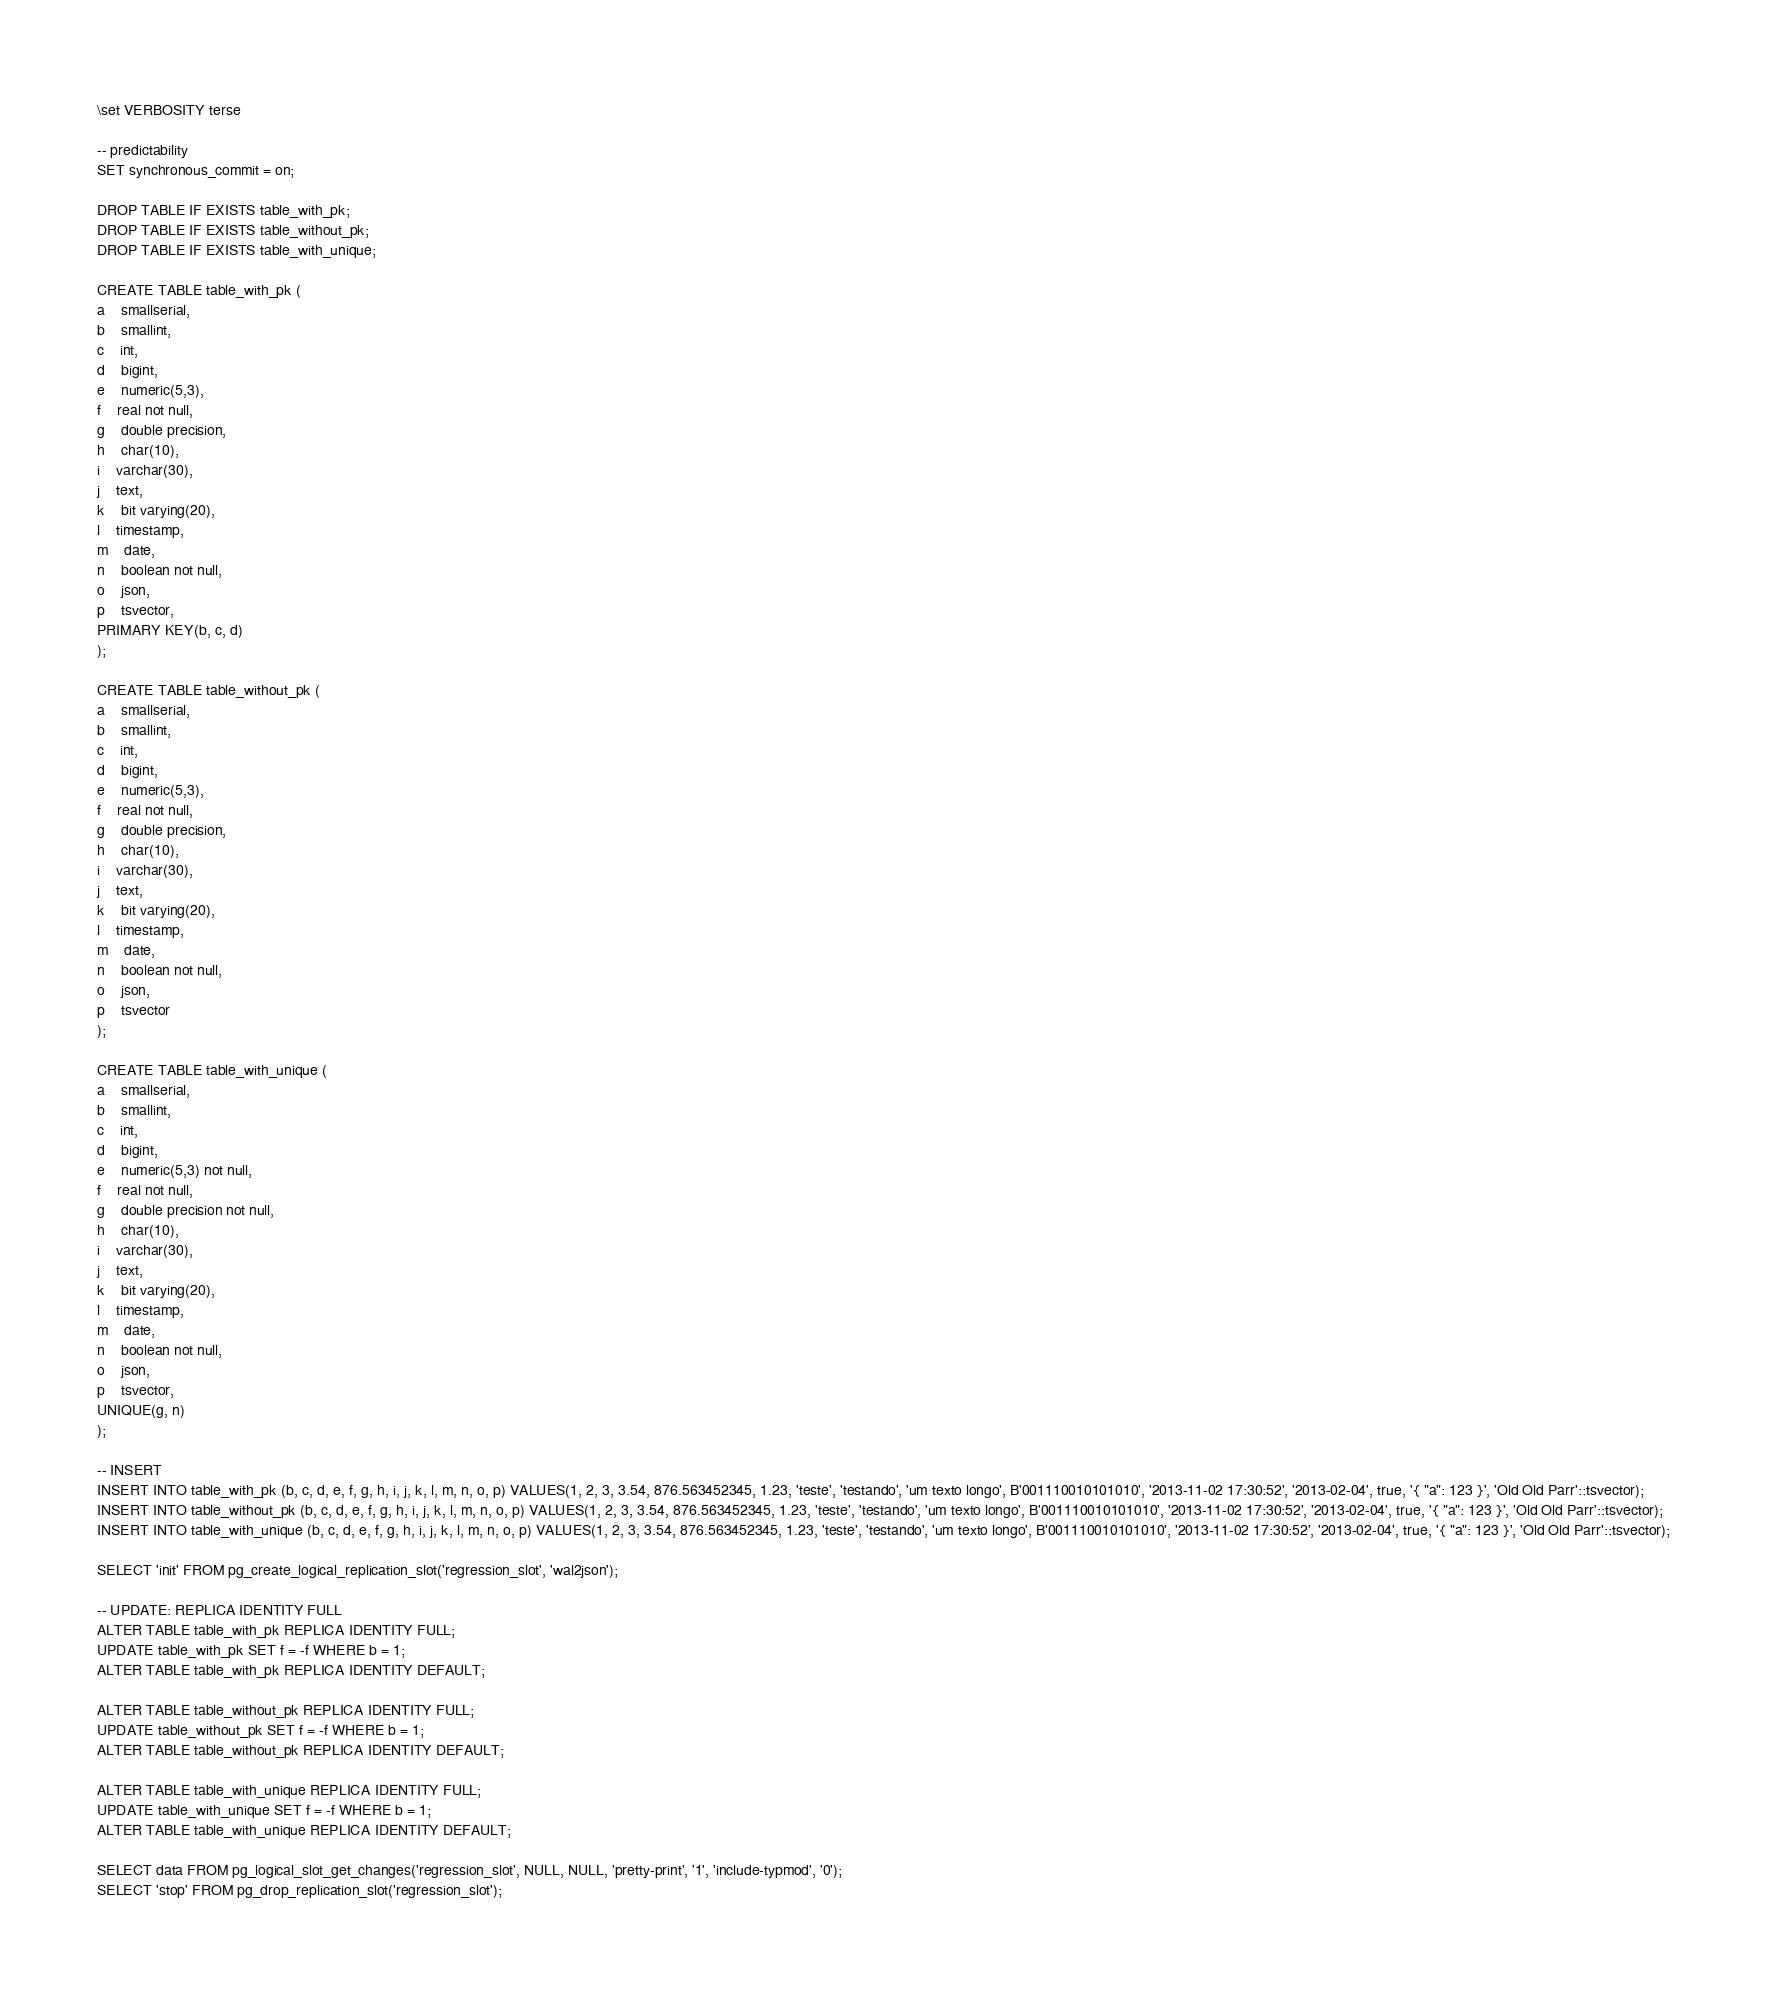<code> <loc_0><loc_0><loc_500><loc_500><_SQL_>\set VERBOSITY terse

-- predictability
SET synchronous_commit = on;

DROP TABLE IF EXISTS table_with_pk;
DROP TABLE IF EXISTS table_without_pk;
DROP TABLE IF EXISTS table_with_unique;

CREATE TABLE table_with_pk (
a	smallserial,
b	smallint,
c	int,
d	bigint,
e	numeric(5,3),
f	real not null,
g	double precision,
h	char(10),
i	varchar(30),
j	text,
k	bit varying(20),
l	timestamp,
m	date,
n	boolean not null,
o	json,
p	tsvector,
PRIMARY KEY(b, c, d)
);

CREATE TABLE table_without_pk (
a	smallserial,
b	smallint,
c	int,
d	bigint,
e	numeric(5,3),
f	real not null,
g	double precision,
h	char(10),
i	varchar(30),
j	text,
k	bit varying(20),
l	timestamp,
m	date,
n	boolean not null,
o	json,
p	tsvector
);

CREATE TABLE table_with_unique (
a	smallserial,
b	smallint,
c	int,
d	bigint,
e	numeric(5,3) not null,
f	real not null,
g	double precision not null,
h	char(10),
i	varchar(30),
j	text,
k	bit varying(20),
l	timestamp,
m	date,
n	boolean not null,
o	json,
p	tsvector,
UNIQUE(g, n)
);

-- INSERT
INSERT INTO table_with_pk (b, c, d, e, f, g, h, i, j, k, l, m, n, o, p) VALUES(1, 2, 3, 3.54, 876.563452345, 1.23, 'teste', 'testando', 'um texto longo', B'001110010101010', '2013-11-02 17:30:52', '2013-02-04', true, '{ "a": 123 }', 'Old Old Parr'::tsvector);
INSERT INTO table_without_pk (b, c, d, e, f, g, h, i, j, k, l, m, n, o, p) VALUES(1, 2, 3, 3.54, 876.563452345, 1.23, 'teste', 'testando', 'um texto longo', B'001110010101010', '2013-11-02 17:30:52', '2013-02-04', true, '{ "a": 123 }', 'Old Old Parr'::tsvector);
INSERT INTO table_with_unique (b, c, d, e, f, g, h, i, j, k, l, m, n, o, p) VALUES(1, 2, 3, 3.54, 876.563452345, 1.23, 'teste', 'testando', 'um texto longo', B'001110010101010', '2013-11-02 17:30:52', '2013-02-04', true, '{ "a": 123 }', 'Old Old Parr'::tsvector);

SELECT 'init' FROM pg_create_logical_replication_slot('regression_slot', 'wal2json');

-- UPDATE: REPLICA IDENTITY FULL
ALTER TABLE table_with_pk REPLICA IDENTITY FULL;
UPDATE table_with_pk SET f = -f WHERE b = 1;
ALTER TABLE table_with_pk REPLICA IDENTITY DEFAULT;

ALTER TABLE table_without_pk REPLICA IDENTITY FULL;
UPDATE table_without_pk SET f = -f WHERE b = 1;
ALTER TABLE table_without_pk REPLICA IDENTITY DEFAULT;

ALTER TABLE table_with_unique REPLICA IDENTITY FULL;
UPDATE table_with_unique SET f = -f WHERE b = 1;
ALTER TABLE table_with_unique REPLICA IDENTITY DEFAULT;

SELECT data FROM pg_logical_slot_get_changes('regression_slot', NULL, NULL, 'pretty-print', '1', 'include-typmod', '0');
SELECT 'stop' FROM pg_drop_replication_slot('regression_slot');
</code> 